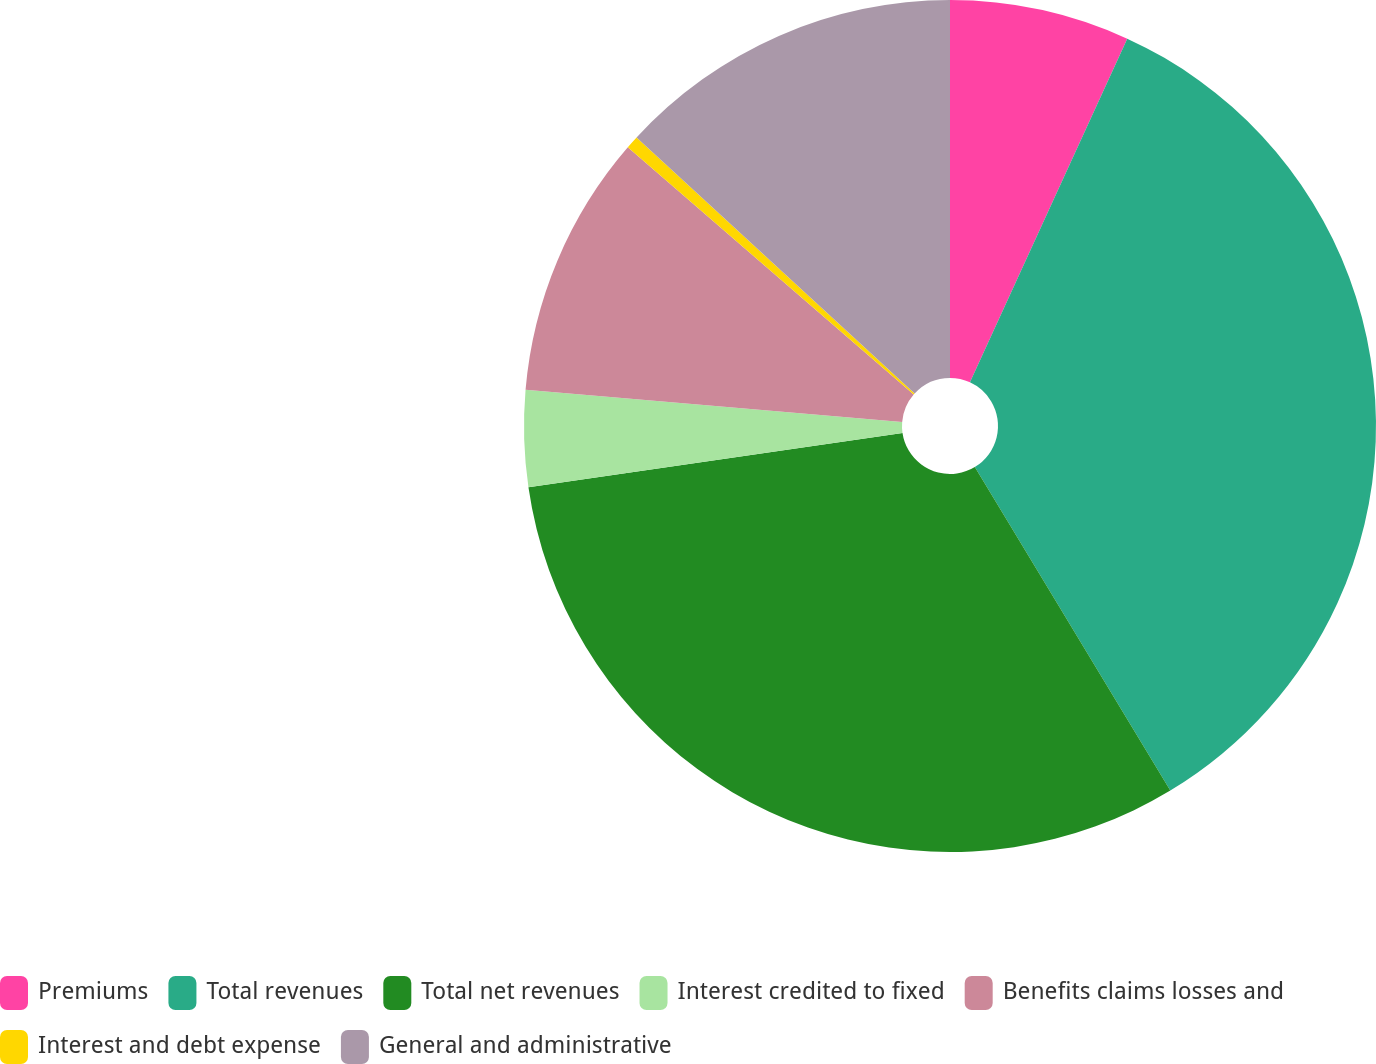Convert chart to OTSL. <chart><loc_0><loc_0><loc_500><loc_500><pie_chart><fcel>Premiums<fcel>Total revenues<fcel>Total net revenues<fcel>Interest credited to fixed<fcel>Benefits claims losses and<fcel>Interest and debt expense<fcel>General and administrative<nl><fcel>6.83%<fcel>34.52%<fcel>31.35%<fcel>3.66%<fcel>9.99%<fcel>0.49%<fcel>13.16%<nl></chart> 